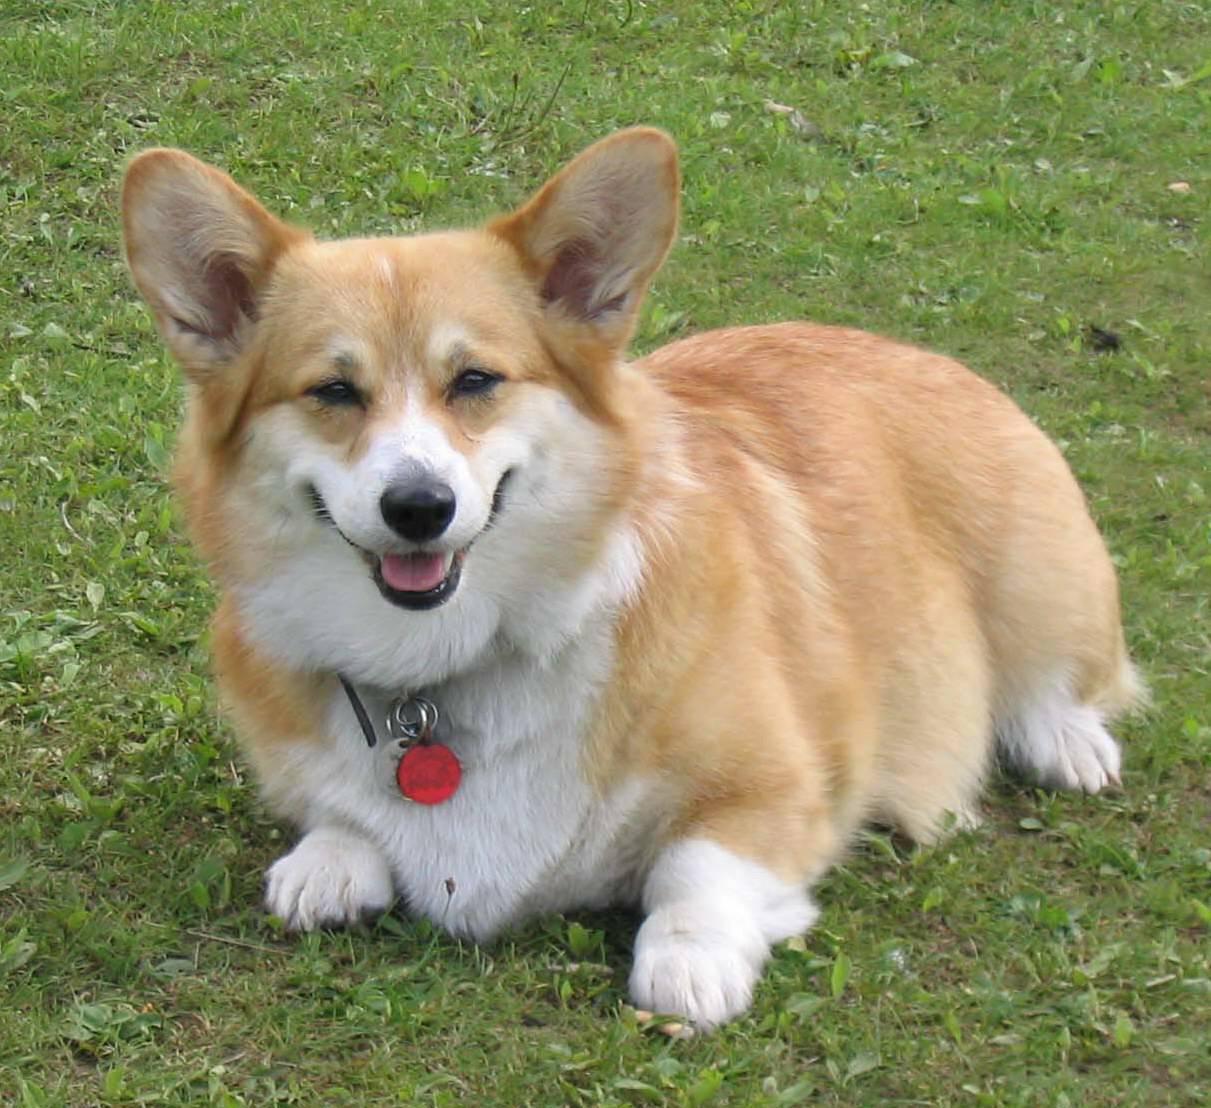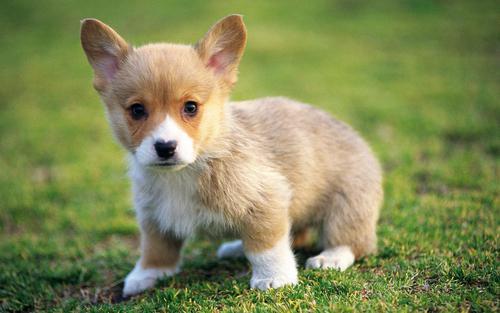The first image is the image on the left, the second image is the image on the right. Considering the images on both sides, is "There is at least three dogs." valid? Answer yes or no. No. The first image is the image on the left, the second image is the image on the right. For the images shown, is this caption "One image contains two dogs, sitting on a wooden slat deck or floor, while no image in the set contains green grass." true? Answer yes or no. No. 